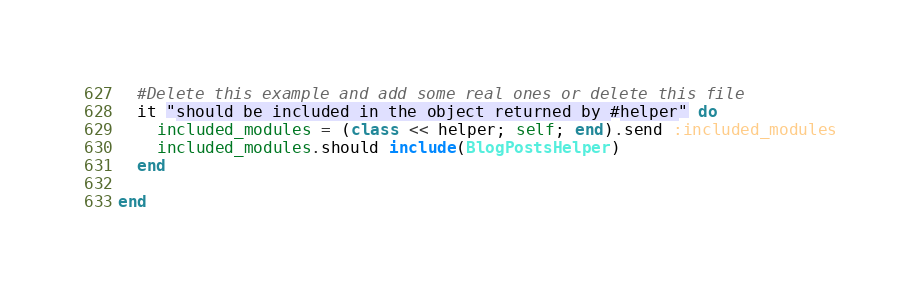Convert code to text. <code><loc_0><loc_0><loc_500><loc_500><_Ruby_>  #Delete this example and add some real ones or delete this file
  it "should be included in the object returned by #helper" do
    included_modules = (class << helper; self; end).send :included_modules
    included_modules.should include(BlogPostsHelper)
  end

end
</code> 